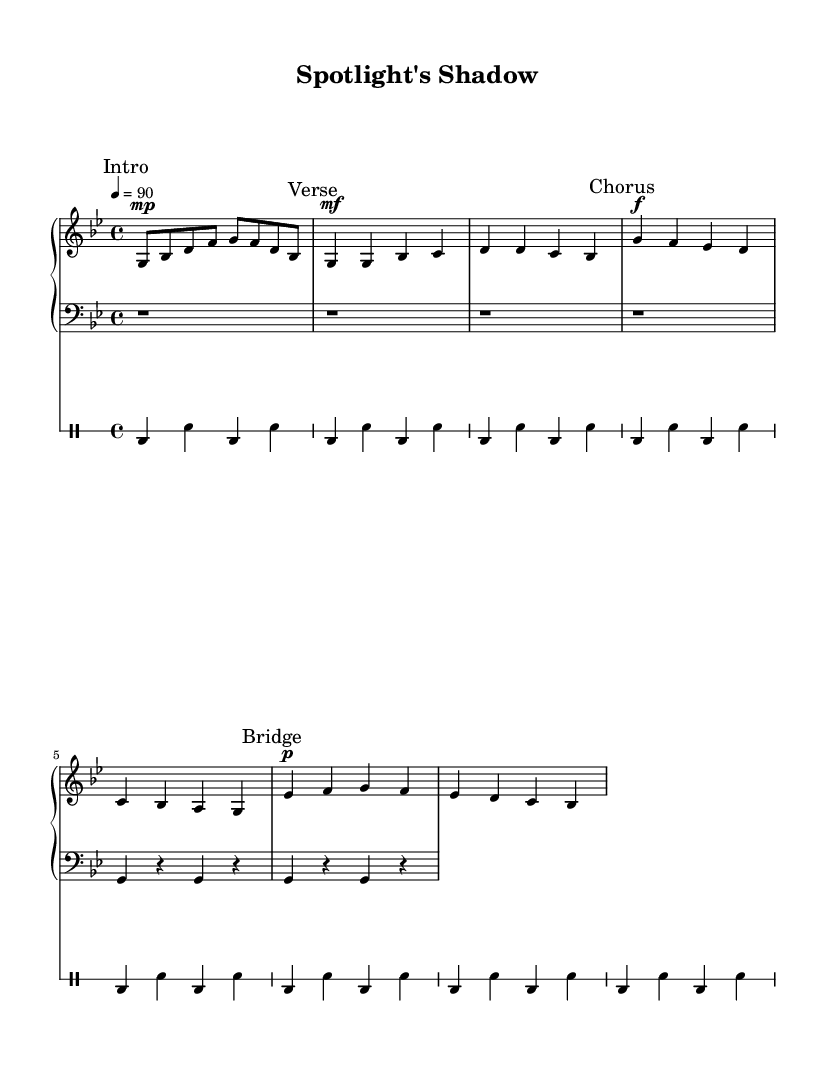What is the key signature of this music? The key signature is G minor, which has two flats (B♭ and E♭). This can be seen indicated on the left side of the staff at the beginning of the piece.
Answer: G minor What is the time signature of the piece? The time signature is 4/4, which allows for four beats per measure. This information is located at the beginning of the staff.
Answer: 4/4 What is the tempo marking provided in the music? The tempo marking is quarter note equals 90, indicating a moderate pace. This is shown at the start of the piece, guiding the performers on speed.
Answer: 90 In which section does the music transition to a louder dynamic? The transition to a louder dynamic occurs in the Chorus, which is marked with a forte dynamic. This can be identified by the "Chorus" marking and the "f" dynamic marking in that section.
Answer: Chorus How many measures are there in the Intro section? The Intro section contains one complete measure, as indicated by the notes and the way they are grouped in the visual representation.
Answer: 1 What note does the verse start on? The verse starts on the note G, which can be observed as the first note in the Verse section.
Answer: G What style of music is this piece categorized under? This piece is categorized under Rap, as indicated by its lyrical structure and thematic focus, which addresses the pressures of fame inspired by Michael Jackson.
Answer: Rap 